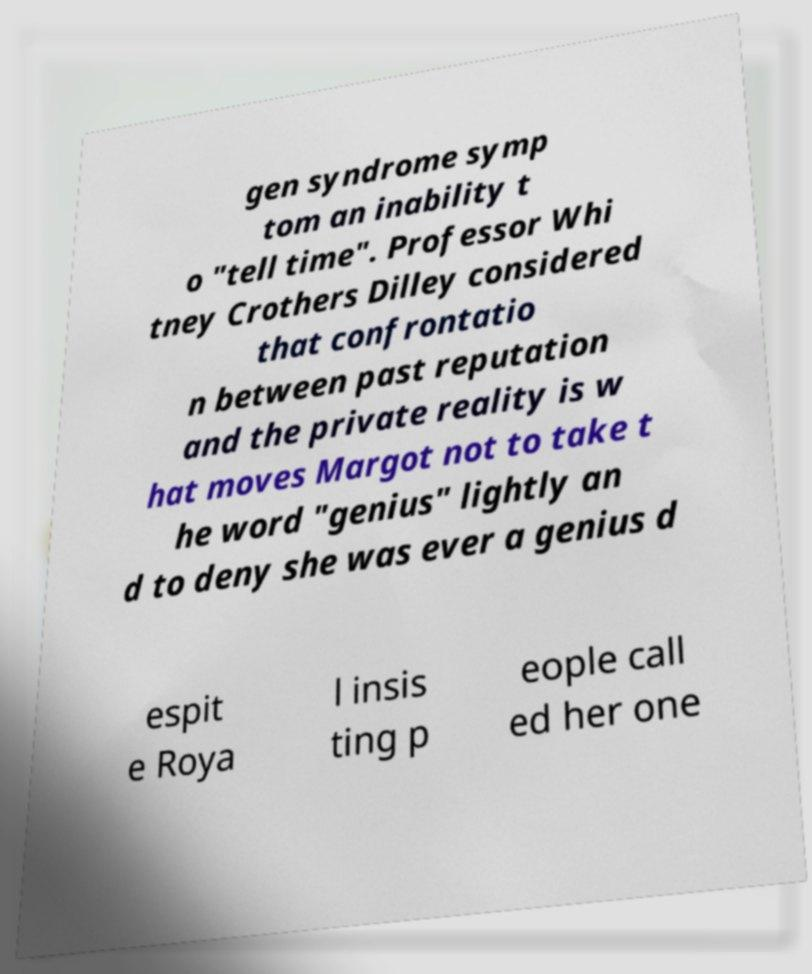Can you accurately transcribe the text from the provided image for me? gen syndrome symp tom an inability t o "tell time". Professor Whi tney Crothers Dilley considered that confrontatio n between past reputation and the private reality is w hat moves Margot not to take t he word "genius" lightly an d to deny she was ever a genius d espit e Roya l insis ting p eople call ed her one 